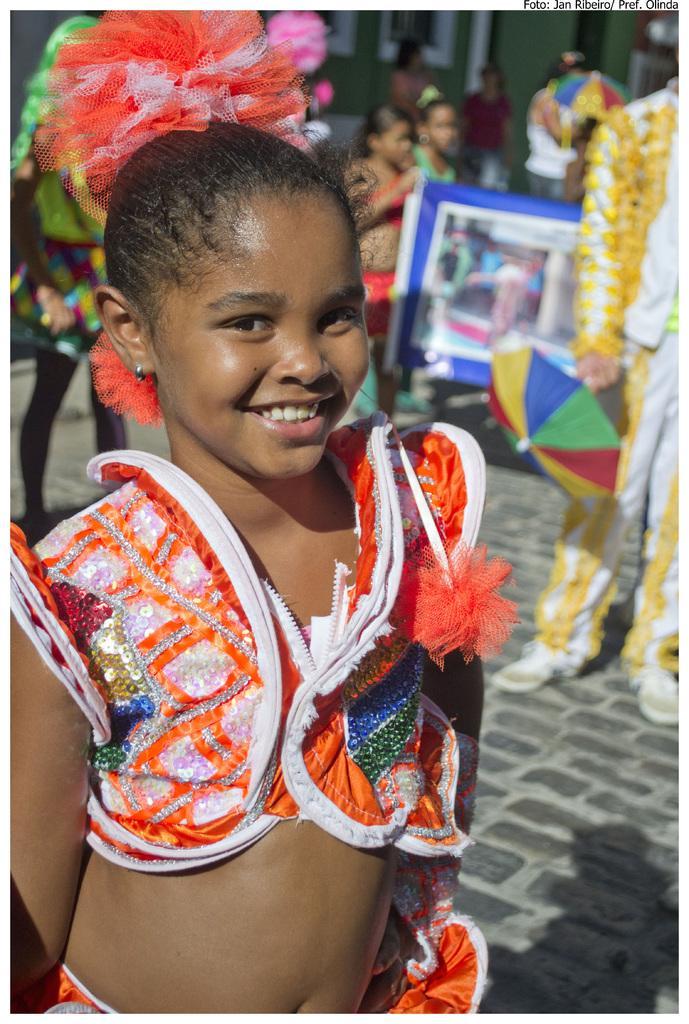How would you summarize this image in a sentence or two? In this image we can see a girl. She is wearing orange color dress. Background of the image people are present. 